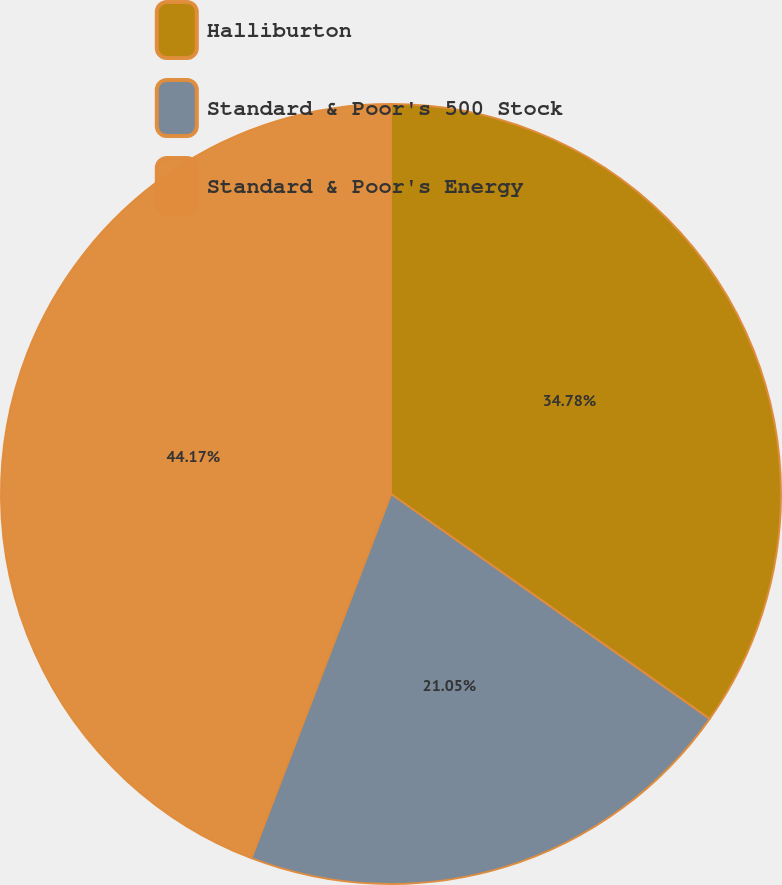Convert chart. <chart><loc_0><loc_0><loc_500><loc_500><pie_chart><fcel>Halliburton<fcel>Standard & Poor's 500 Stock<fcel>Standard & Poor's Energy<nl><fcel>34.78%<fcel>21.05%<fcel>44.17%<nl></chart> 